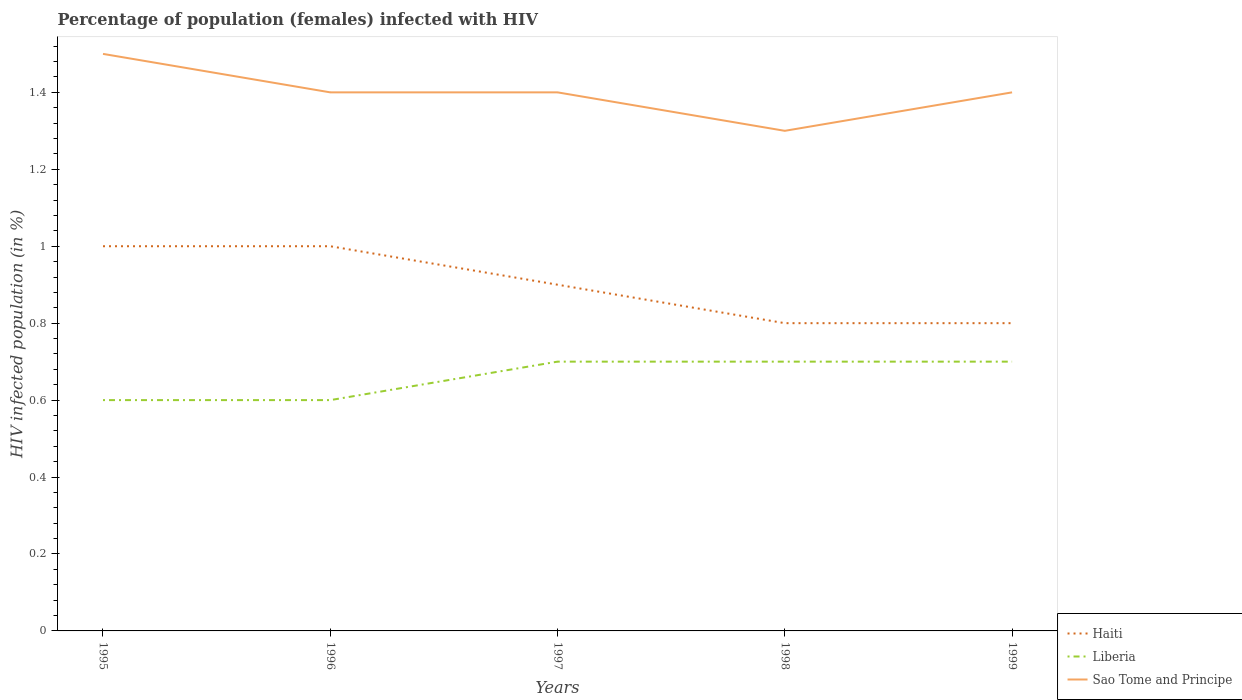Is the number of lines equal to the number of legend labels?
Offer a very short reply. Yes. Across all years, what is the maximum percentage of HIV infected female population in Haiti?
Your answer should be compact. 0.8. In which year was the percentage of HIV infected female population in Liberia maximum?
Offer a terse response. 1995. What is the difference between the highest and the second highest percentage of HIV infected female population in Haiti?
Offer a terse response. 0.2. Is the percentage of HIV infected female population in Sao Tome and Principe strictly greater than the percentage of HIV infected female population in Liberia over the years?
Offer a very short reply. No. Does the graph contain any zero values?
Provide a succinct answer. No. Does the graph contain grids?
Keep it short and to the point. No. What is the title of the graph?
Your answer should be compact. Percentage of population (females) infected with HIV. What is the label or title of the Y-axis?
Your answer should be very brief. HIV infected population (in %). What is the HIV infected population (in %) in Liberia in 1995?
Offer a very short reply. 0.6. What is the HIV infected population (in %) in Haiti in 1997?
Offer a terse response. 0.9. What is the HIV infected population (in %) of Liberia in 1997?
Your answer should be compact. 0.7. What is the HIV infected population (in %) in Sao Tome and Principe in 1997?
Make the answer very short. 1.4. What is the HIV infected population (in %) in Sao Tome and Principe in 1999?
Provide a short and direct response. 1.4. Across all years, what is the maximum HIV infected population (in %) in Sao Tome and Principe?
Offer a terse response. 1.5. Across all years, what is the minimum HIV infected population (in %) of Liberia?
Your response must be concise. 0.6. Across all years, what is the minimum HIV infected population (in %) in Sao Tome and Principe?
Give a very brief answer. 1.3. What is the total HIV infected population (in %) of Sao Tome and Principe in the graph?
Your answer should be compact. 7. What is the difference between the HIV infected population (in %) of Haiti in 1995 and that in 1998?
Provide a succinct answer. 0.2. What is the difference between the HIV infected population (in %) of Haiti in 1995 and that in 1999?
Your response must be concise. 0.2. What is the difference between the HIV infected population (in %) of Sao Tome and Principe in 1996 and that in 1997?
Keep it short and to the point. 0. What is the difference between the HIV infected population (in %) of Liberia in 1996 and that in 1998?
Your response must be concise. -0.1. What is the difference between the HIV infected population (in %) in Haiti in 1996 and that in 1999?
Give a very brief answer. 0.2. What is the difference between the HIV infected population (in %) of Liberia in 1997 and that in 1998?
Offer a very short reply. 0. What is the difference between the HIV infected population (in %) of Liberia in 1997 and that in 1999?
Ensure brevity in your answer.  0. What is the difference between the HIV infected population (in %) in Haiti in 1998 and that in 1999?
Offer a very short reply. 0. What is the difference between the HIV infected population (in %) in Liberia in 1998 and that in 1999?
Offer a very short reply. 0. What is the difference between the HIV infected population (in %) in Haiti in 1995 and the HIV infected population (in %) in Liberia in 1996?
Your response must be concise. 0.4. What is the difference between the HIV infected population (in %) in Haiti in 1995 and the HIV infected population (in %) in Sao Tome and Principe in 1996?
Keep it short and to the point. -0.4. What is the difference between the HIV infected population (in %) in Haiti in 1995 and the HIV infected population (in %) in Liberia in 1997?
Provide a short and direct response. 0.3. What is the difference between the HIV infected population (in %) of Haiti in 1995 and the HIV infected population (in %) of Sao Tome and Principe in 1997?
Offer a terse response. -0.4. What is the difference between the HIV infected population (in %) in Liberia in 1995 and the HIV infected population (in %) in Sao Tome and Principe in 1997?
Your answer should be compact. -0.8. What is the difference between the HIV infected population (in %) of Haiti in 1995 and the HIV infected population (in %) of Liberia in 1998?
Offer a very short reply. 0.3. What is the difference between the HIV infected population (in %) of Haiti in 1995 and the HIV infected population (in %) of Sao Tome and Principe in 1998?
Provide a succinct answer. -0.3. What is the difference between the HIV infected population (in %) in Haiti in 1995 and the HIV infected population (in %) in Liberia in 1999?
Provide a succinct answer. 0.3. What is the difference between the HIV infected population (in %) in Liberia in 1995 and the HIV infected population (in %) in Sao Tome and Principe in 1999?
Ensure brevity in your answer.  -0.8. What is the difference between the HIV infected population (in %) of Haiti in 1996 and the HIV infected population (in %) of Sao Tome and Principe in 1997?
Your answer should be compact. -0.4. What is the difference between the HIV infected population (in %) of Haiti in 1996 and the HIV infected population (in %) of Sao Tome and Principe in 1998?
Offer a terse response. -0.3. What is the difference between the HIV infected population (in %) in Liberia in 1996 and the HIV infected population (in %) in Sao Tome and Principe in 1998?
Keep it short and to the point. -0.7. What is the difference between the HIV infected population (in %) of Haiti in 1996 and the HIV infected population (in %) of Liberia in 1999?
Offer a very short reply. 0.3. What is the difference between the HIV infected population (in %) of Haiti in 1997 and the HIV infected population (in %) of Liberia in 1998?
Your response must be concise. 0.2. What is the difference between the HIV infected population (in %) of Liberia in 1997 and the HIV infected population (in %) of Sao Tome and Principe in 1998?
Offer a very short reply. -0.6. What is the difference between the HIV infected population (in %) of Haiti in 1997 and the HIV infected population (in %) of Sao Tome and Principe in 1999?
Your answer should be very brief. -0.5. What is the difference between the HIV infected population (in %) of Liberia in 1997 and the HIV infected population (in %) of Sao Tome and Principe in 1999?
Offer a very short reply. -0.7. What is the average HIV infected population (in %) in Liberia per year?
Provide a succinct answer. 0.66. What is the average HIV infected population (in %) of Sao Tome and Principe per year?
Offer a very short reply. 1.4. In the year 1995, what is the difference between the HIV infected population (in %) of Haiti and HIV infected population (in %) of Liberia?
Your response must be concise. 0.4. In the year 1995, what is the difference between the HIV infected population (in %) in Haiti and HIV infected population (in %) in Sao Tome and Principe?
Your response must be concise. -0.5. In the year 1996, what is the difference between the HIV infected population (in %) of Haiti and HIV infected population (in %) of Liberia?
Provide a short and direct response. 0.4. In the year 1996, what is the difference between the HIV infected population (in %) in Haiti and HIV infected population (in %) in Sao Tome and Principe?
Offer a terse response. -0.4. In the year 1997, what is the difference between the HIV infected population (in %) of Haiti and HIV infected population (in %) of Liberia?
Keep it short and to the point. 0.2. In the year 1997, what is the difference between the HIV infected population (in %) in Haiti and HIV infected population (in %) in Sao Tome and Principe?
Keep it short and to the point. -0.5. In the year 1998, what is the difference between the HIV infected population (in %) of Liberia and HIV infected population (in %) of Sao Tome and Principe?
Provide a succinct answer. -0.6. What is the ratio of the HIV infected population (in %) in Haiti in 1995 to that in 1996?
Keep it short and to the point. 1. What is the ratio of the HIV infected population (in %) in Sao Tome and Principe in 1995 to that in 1996?
Offer a terse response. 1.07. What is the ratio of the HIV infected population (in %) of Sao Tome and Principe in 1995 to that in 1997?
Ensure brevity in your answer.  1.07. What is the ratio of the HIV infected population (in %) in Haiti in 1995 to that in 1998?
Your answer should be very brief. 1.25. What is the ratio of the HIV infected population (in %) of Sao Tome and Principe in 1995 to that in 1998?
Provide a succinct answer. 1.15. What is the ratio of the HIV infected population (in %) in Haiti in 1995 to that in 1999?
Offer a very short reply. 1.25. What is the ratio of the HIV infected population (in %) of Sao Tome and Principe in 1995 to that in 1999?
Ensure brevity in your answer.  1.07. What is the ratio of the HIV infected population (in %) in Sao Tome and Principe in 1996 to that in 1997?
Your answer should be compact. 1. What is the ratio of the HIV infected population (in %) of Haiti in 1996 to that in 1999?
Your answer should be compact. 1.25. What is the ratio of the HIV infected population (in %) in Sao Tome and Principe in 1996 to that in 1999?
Provide a succinct answer. 1. What is the ratio of the HIV infected population (in %) of Haiti in 1997 to that in 1998?
Your answer should be compact. 1.12. What is the ratio of the HIV infected population (in %) in Sao Tome and Principe in 1997 to that in 1998?
Your response must be concise. 1.08. What is the ratio of the HIV infected population (in %) in Haiti in 1997 to that in 1999?
Keep it short and to the point. 1.12. What is the ratio of the HIV infected population (in %) of Sao Tome and Principe in 1997 to that in 1999?
Offer a terse response. 1. What is the ratio of the HIV infected population (in %) in Haiti in 1998 to that in 1999?
Provide a short and direct response. 1. What is the ratio of the HIV infected population (in %) of Sao Tome and Principe in 1998 to that in 1999?
Offer a very short reply. 0.93. What is the difference between the highest and the second highest HIV infected population (in %) of Haiti?
Give a very brief answer. 0. What is the difference between the highest and the second highest HIV infected population (in %) in Liberia?
Your answer should be very brief. 0. What is the difference between the highest and the lowest HIV infected population (in %) of Liberia?
Keep it short and to the point. 0.1. 